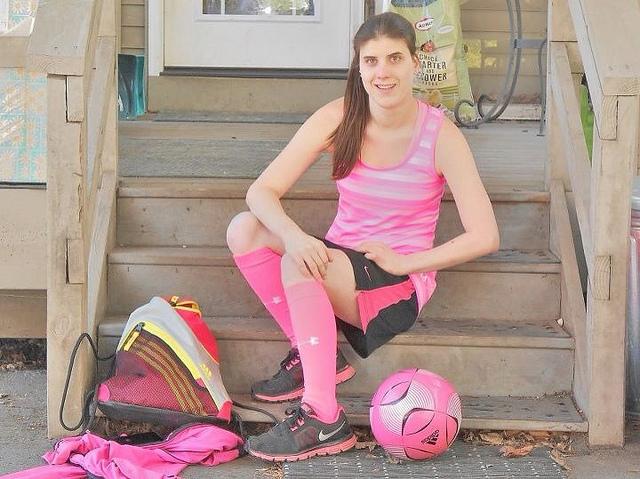What brand are the girl's shoes?
Quick response, please. Nike. What color stands out in this picture?
Give a very brief answer. Pink. What is she sitting on?
Be succinct. Stairs. 